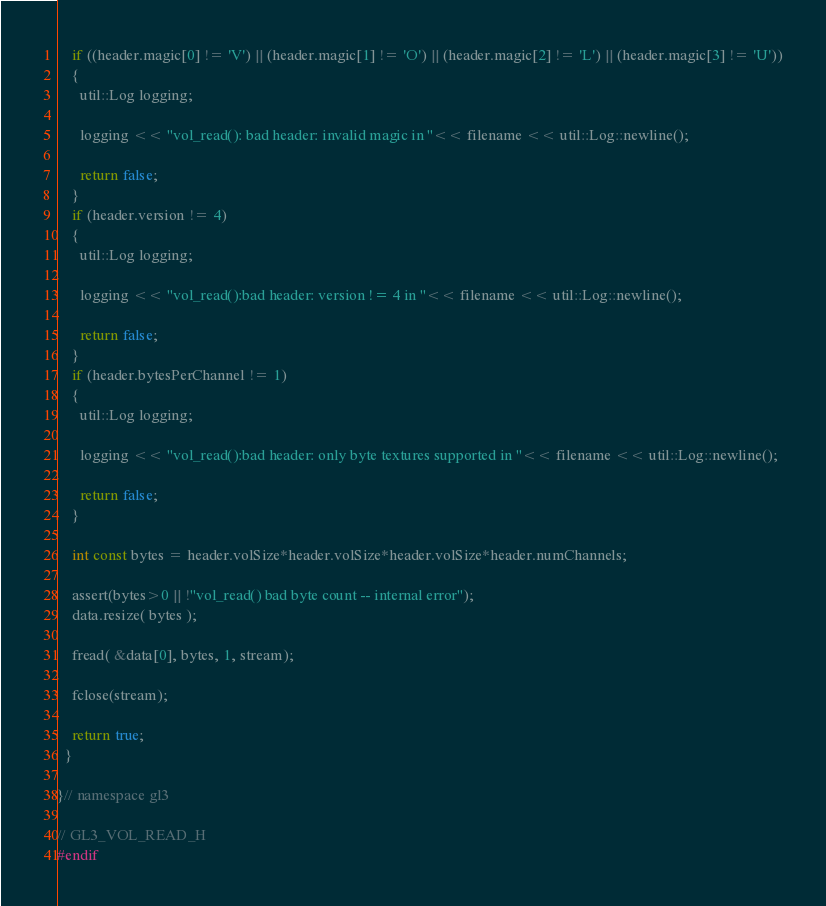Convert code to text. <code><loc_0><loc_0><loc_500><loc_500><_C_>
    if ((header.magic[0] != 'V') || (header.magic[1] != 'O') || (header.magic[2] != 'L') || (header.magic[3] != 'U'))
    {
      util::Log logging;

      logging << "vol_read(): bad header: invalid magic in "<< filename << util::Log::newline();

      return false;
    }
    if (header.version != 4)
    {
      util::Log logging;

      logging << "vol_read():bad header: version != 4 in "<< filename << util::Log::newline();

      return false;
    }
    if (header.bytesPerChannel != 1)
    {
      util::Log logging;

      logging << "vol_read():bad header: only byte textures supported in "<< filename << util::Log::newline();

      return false;
    }

    int const bytes = header.volSize*header.volSize*header.volSize*header.numChannels;

    assert(bytes>0 || !"vol_read() bad byte count -- internal error");
    data.resize( bytes );

    fread( &data[0], bytes, 1, stream);

    fclose(stream);

    return true;
  }

}// namespace gl3

// GL3_VOL_READ_H
#endif
</code> 